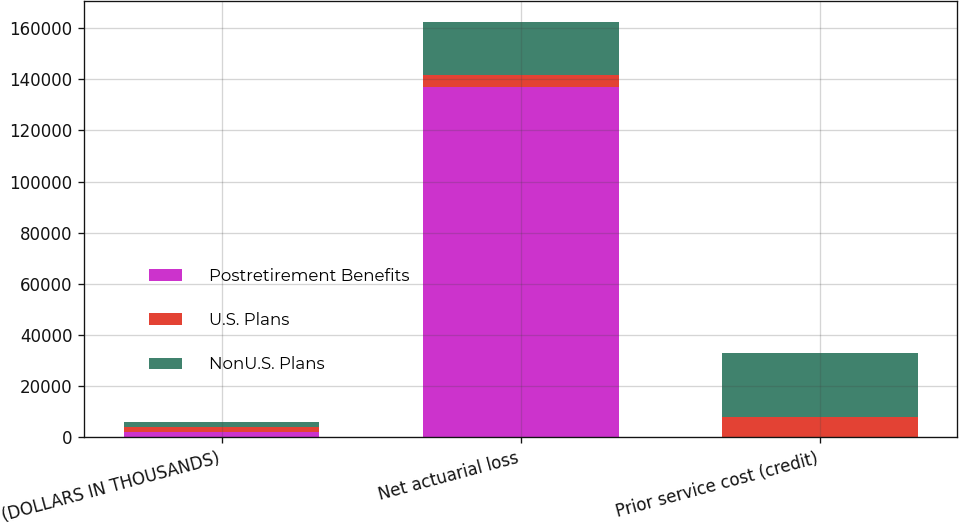Convert chart. <chart><loc_0><loc_0><loc_500><loc_500><stacked_bar_chart><ecel><fcel>(DOLLARS IN THOUSANDS)<fcel>Net actuarial loss<fcel>Prior service cost (credit)<nl><fcel>Postretirement Benefits<fcel>2017<fcel>136888<fcel>194<nl><fcel>U.S. Plans<fcel>2017<fcel>4826<fcel>7635<nl><fcel>NonU.S. Plans<fcel>2017<fcel>20810<fcel>25330<nl></chart> 